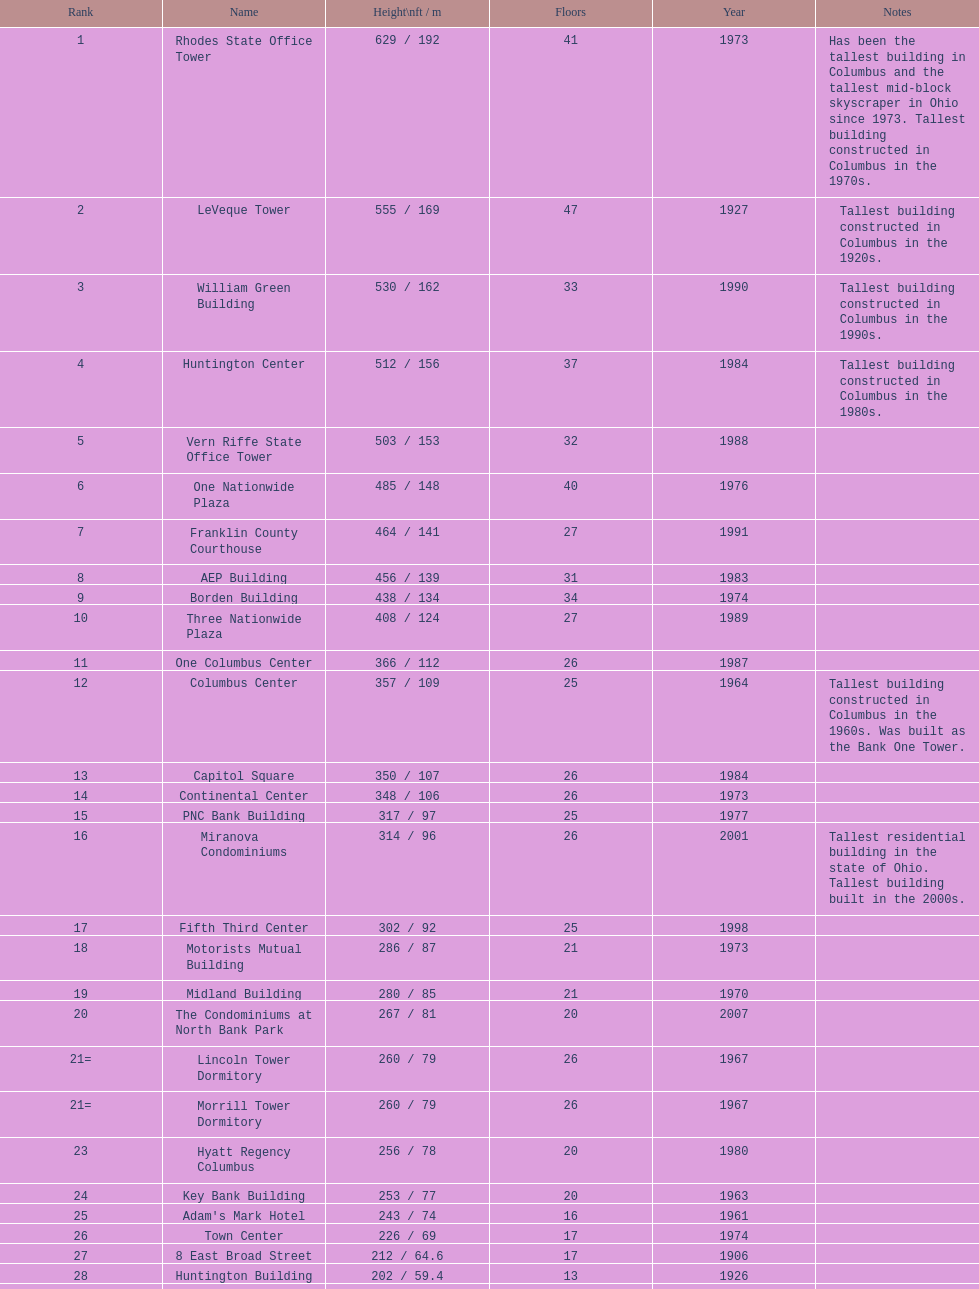What number of floors does the leveque tower have? 47. 